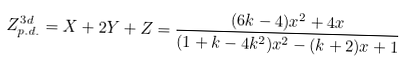<formula> <loc_0><loc_0><loc_500><loc_500>Z ^ { 3 d } _ { p . d . } = X + 2 Y + Z = \frac { ( 6 k - 4 ) x ^ { 2 } + 4 x } { ( 1 + k - 4 k ^ { 2 } ) x ^ { 2 } - ( k + 2 ) x + 1 }</formula> 